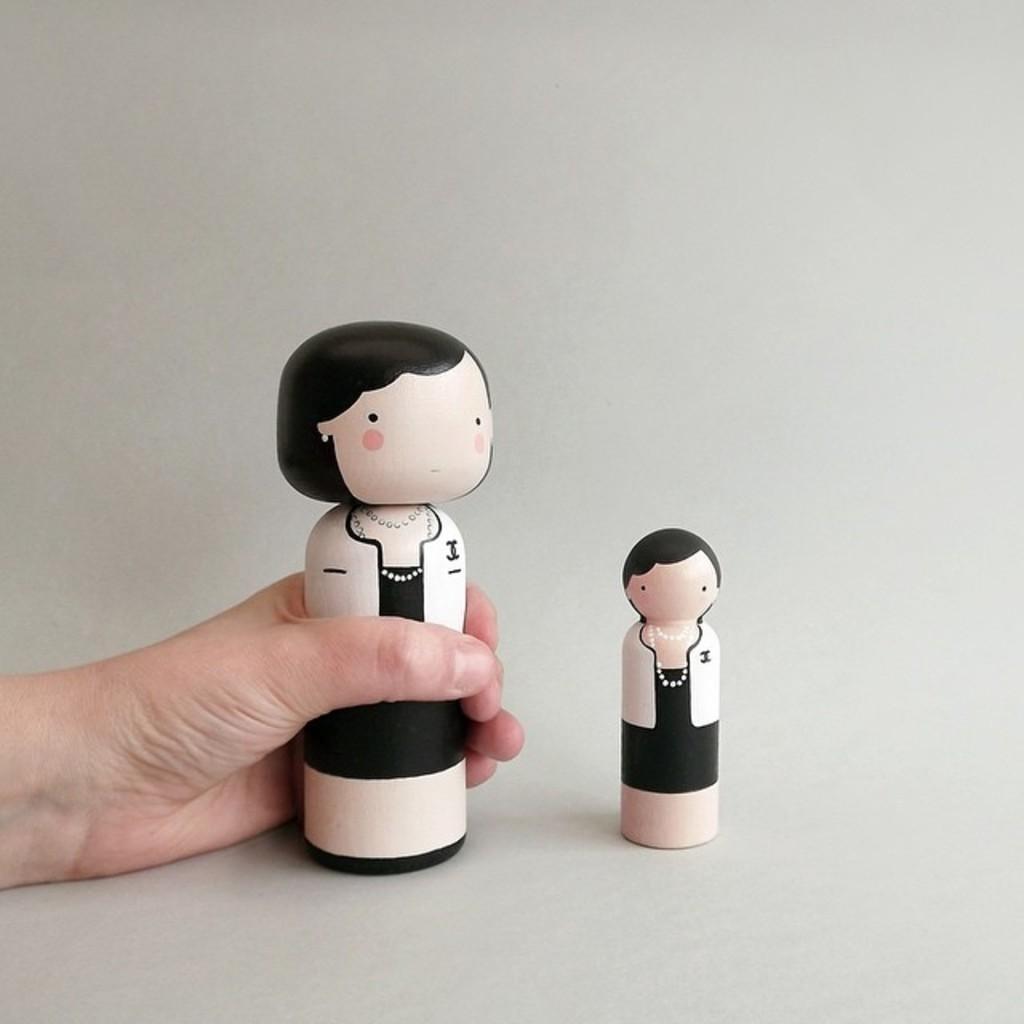In one or two sentences, can you explain what this image depicts? In a given image I can see a human hand holding an object and the background is white. 